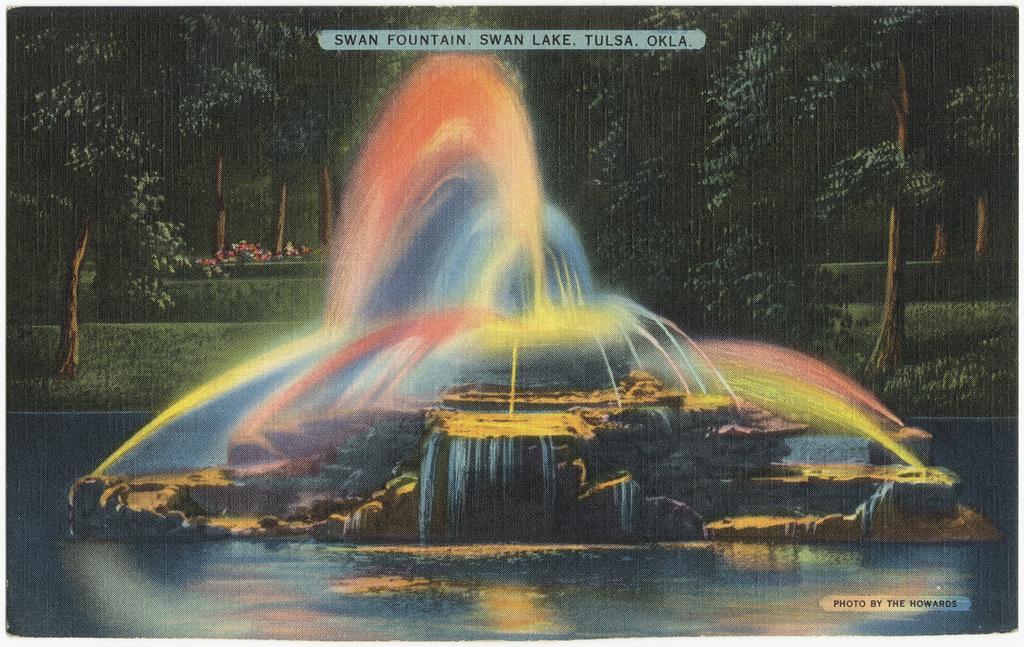How would you summarize this image in a sentence or two? Here we can see colorful water fountain. Background there are trees, grass and plants. These are watermarks. 